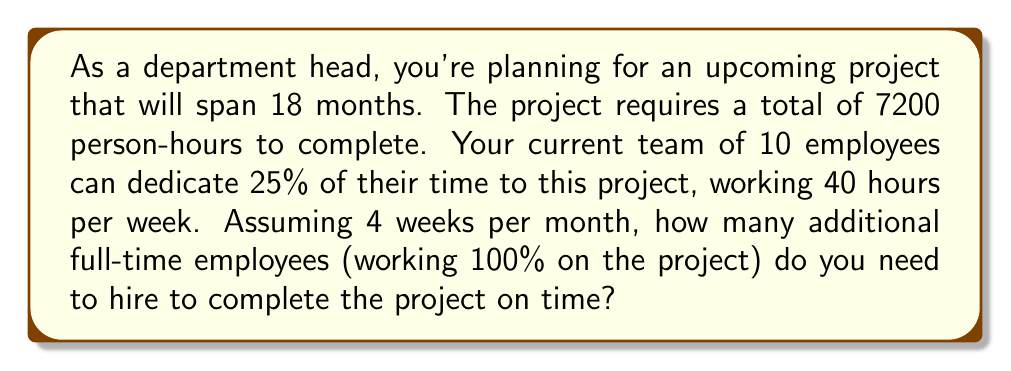Show me your answer to this math problem. Let's break this down step-by-step:

1) First, calculate the total available hours from the current team:
   - 10 employees × 40 hours/week × 25% dedication = 100 hours/week
   - 100 hours/week × 4 weeks/month × 18 months = 7200 hours

2) Now, calculate the total hours needed for the project:
   - Given: 7200 person-hours

3) The current team can provide exactly 7200 hours, which matches the project needs. However, this assumes they work continuously for 18 months without any breaks or holidays.

4) To account for vacations, sick days, and other time off, let's assume employees work effectively 46 weeks per year (allowing 6 weeks for time off and holidays).

5) Recalculate the available hours from the current team:
   - 18 months = 1.5 years
   - 46 weeks/year × 1.5 years = 69 weeks
   - 100 hours/week × 69 weeks = 6900 hours

6) Calculate the shortfall:
   - 7200 hours needed - 6900 hours available = 300 hours shortfall

7) Calculate how many hours a full-time employee can provide over 18 months:
   - 40 hours/week × 69 weeks = 2760 hours

8) Calculate the number of additional full-time employees needed:
   $$\text{Additional employees} = \frac{\text{Shortfall hours}}{\text{Hours per full-time employee}} = \frac{300}{2760} \approx 0.109$$

9) Since we can't hire a fraction of an employee, we need to round up to the nearest whole number.
Answer: 1 additional full-time employee 